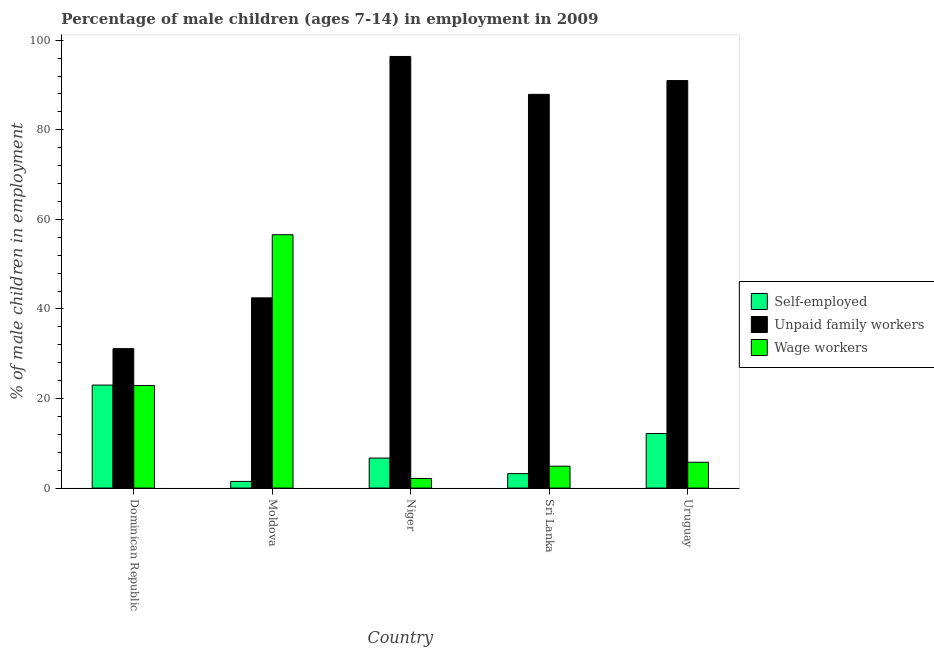How many groups of bars are there?
Your answer should be very brief. 5. Are the number of bars per tick equal to the number of legend labels?
Keep it short and to the point. Yes. Are the number of bars on each tick of the X-axis equal?
Make the answer very short. Yes. How many bars are there on the 2nd tick from the left?
Your answer should be compact. 3. How many bars are there on the 3rd tick from the right?
Your answer should be very brief. 3. What is the label of the 1st group of bars from the left?
Your answer should be very brief. Dominican Republic. What is the percentage of self employed children in Sri Lanka?
Your answer should be compact. 3.23. Across all countries, what is the maximum percentage of self employed children?
Offer a very short reply. 23. Across all countries, what is the minimum percentage of self employed children?
Offer a terse response. 1.49. In which country was the percentage of children employed as wage workers maximum?
Offer a terse response. Moldova. In which country was the percentage of children employed as unpaid family workers minimum?
Give a very brief answer. Dominican Republic. What is the total percentage of self employed children in the graph?
Keep it short and to the point. 46.6. What is the difference between the percentage of self employed children in Dominican Republic and that in Uruguay?
Your response must be concise. 10.82. What is the difference between the percentage of children employed as unpaid family workers in Niger and the percentage of children employed as wage workers in Moldova?
Provide a short and direct response. 39.81. What is the average percentage of children employed as wage workers per country?
Make the answer very short. 18.45. What is the difference between the percentage of children employed as wage workers and percentage of children employed as unpaid family workers in Moldova?
Make the answer very short. 14.09. In how many countries, is the percentage of children employed as unpaid family workers greater than 48 %?
Give a very brief answer. 3. What is the ratio of the percentage of self employed children in Moldova to that in Uruguay?
Make the answer very short. 0.12. Is the percentage of self employed children in Niger less than that in Uruguay?
Provide a succinct answer. Yes. Is the difference between the percentage of children employed as unpaid family workers in Niger and Sri Lanka greater than the difference between the percentage of children employed as wage workers in Niger and Sri Lanka?
Make the answer very short. Yes. What is the difference between the highest and the second highest percentage of children employed as wage workers?
Ensure brevity in your answer.  33.67. What is the difference between the highest and the lowest percentage of self employed children?
Your answer should be compact. 21.51. In how many countries, is the percentage of children employed as unpaid family workers greater than the average percentage of children employed as unpaid family workers taken over all countries?
Ensure brevity in your answer.  3. Is the sum of the percentage of children employed as unpaid family workers in Moldova and Uruguay greater than the maximum percentage of self employed children across all countries?
Keep it short and to the point. Yes. What does the 3rd bar from the left in Niger represents?
Provide a succinct answer. Wage workers. What does the 1st bar from the right in Dominican Republic represents?
Your answer should be compact. Wage workers. Are all the bars in the graph horizontal?
Your answer should be compact. No. How many countries are there in the graph?
Your response must be concise. 5. Are the values on the major ticks of Y-axis written in scientific E-notation?
Offer a very short reply. No. Does the graph contain grids?
Make the answer very short. No. Where does the legend appear in the graph?
Provide a succinct answer. Center right. How are the legend labels stacked?
Ensure brevity in your answer.  Vertical. What is the title of the graph?
Make the answer very short. Percentage of male children (ages 7-14) in employment in 2009. Does "Male employers" appear as one of the legend labels in the graph?
Give a very brief answer. No. What is the label or title of the Y-axis?
Your answer should be very brief. % of male children in employment. What is the % of male children in employment in Unpaid family workers in Dominican Republic?
Ensure brevity in your answer.  31.14. What is the % of male children in employment of Wage workers in Dominican Republic?
Provide a succinct answer. 22.9. What is the % of male children in employment in Self-employed in Moldova?
Your response must be concise. 1.49. What is the % of male children in employment in Unpaid family workers in Moldova?
Your response must be concise. 42.48. What is the % of male children in employment of Wage workers in Moldova?
Your answer should be very brief. 56.57. What is the % of male children in employment in Unpaid family workers in Niger?
Ensure brevity in your answer.  96.38. What is the % of male children in employment of Wage workers in Niger?
Offer a very short reply. 2.14. What is the % of male children in employment in Self-employed in Sri Lanka?
Provide a short and direct response. 3.23. What is the % of male children in employment in Unpaid family workers in Sri Lanka?
Provide a succinct answer. 87.92. What is the % of male children in employment of Wage workers in Sri Lanka?
Ensure brevity in your answer.  4.89. What is the % of male children in employment of Self-employed in Uruguay?
Ensure brevity in your answer.  12.18. What is the % of male children in employment of Unpaid family workers in Uruguay?
Offer a terse response. 91. What is the % of male children in employment of Wage workers in Uruguay?
Keep it short and to the point. 5.77. Across all countries, what is the maximum % of male children in employment in Self-employed?
Make the answer very short. 23. Across all countries, what is the maximum % of male children in employment of Unpaid family workers?
Provide a short and direct response. 96.38. Across all countries, what is the maximum % of male children in employment of Wage workers?
Provide a short and direct response. 56.57. Across all countries, what is the minimum % of male children in employment in Self-employed?
Provide a succinct answer. 1.49. Across all countries, what is the minimum % of male children in employment in Unpaid family workers?
Your answer should be compact. 31.14. Across all countries, what is the minimum % of male children in employment of Wage workers?
Offer a very short reply. 2.14. What is the total % of male children in employment of Self-employed in the graph?
Give a very brief answer. 46.6. What is the total % of male children in employment in Unpaid family workers in the graph?
Your response must be concise. 348.92. What is the total % of male children in employment of Wage workers in the graph?
Keep it short and to the point. 92.27. What is the difference between the % of male children in employment in Self-employed in Dominican Republic and that in Moldova?
Provide a short and direct response. 21.51. What is the difference between the % of male children in employment in Unpaid family workers in Dominican Republic and that in Moldova?
Give a very brief answer. -11.34. What is the difference between the % of male children in employment of Wage workers in Dominican Republic and that in Moldova?
Offer a terse response. -33.67. What is the difference between the % of male children in employment of Self-employed in Dominican Republic and that in Niger?
Provide a short and direct response. 16.3. What is the difference between the % of male children in employment in Unpaid family workers in Dominican Republic and that in Niger?
Your answer should be very brief. -65.24. What is the difference between the % of male children in employment in Wage workers in Dominican Republic and that in Niger?
Make the answer very short. 20.76. What is the difference between the % of male children in employment of Self-employed in Dominican Republic and that in Sri Lanka?
Provide a short and direct response. 19.77. What is the difference between the % of male children in employment in Unpaid family workers in Dominican Republic and that in Sri Lanka?
Offer a very short reply. -56.78. What is the difference between the % of male children in employment in Wage workers in Dominican Republic and that in Sri Lanka?
Your answer should be very brief. 18.01. What is the difference between the % of male children in employment in Self-employed in Dominican Republic and that in Uruguay?
Your answer should be compact. 10.82. What is the difference between the % of male children in employment of Unpaid family workers in Dominican Republic and that in Uruguay?
Give a very brief answer. -59.86. What is the difference between the % of male children in employment in Wage workers in Dominican Republic and that in Uruguay?
Keep it short and to the point. 17.13. What is the difference between the % of male children in employment in Self-employed in Moldova and that in Niger?
Make the answer very short. -5.21. What is the difference between the % of male children in employment in Unpaid family workers in Moldova and that in Niger?
Offer a terse response. -53.9. What is the difference between the % of male children in employment in Wage workers in Moldova and that in Niger?
Your answer should be compact. 54.43. What is the difference between the % of male children in employment of Self-employed in Moldova and that in Sri Lanka?
Provide a short and direct response. -1.74. What is the difference between the % of male children in employment of Unpaid family workers in Moldova and that in Sri Lanka?
Your answer should be compact. -45.44. What is the difference between the % of male children in employment of Wage workers in Moldova and that in Sri Lanka?
Keep it short and to the point. 51.68. What is the difference between the % of male children in employment of Self-employed in Moldova and that in Uruguay?
Provide a short and direct response. -10.69. What is the difference between the % of male children in employment in Unpaid family workers in Moldova and that in Uruguay?
Your answer should be compact. -48.52. What is the difference between the % of male children in employment of Wage workers in Moldova and that in Uruguay?
Keep it short and to the point. 50.8. What is the difference between the % of male children in employment of Self-employed in Niger and that in Sri Lanka?
Your answer should be compact. 3.47. What is the difference between the % of male children in employment of Unpaid family workers in Niger and that in Sri Lanka?
Offer a very short reply. 8.46. What is the difference between the % of male children in employment of Wage workers in Niger and that in Sri Lanka?
Your answer should be compact. -2.75. What is the difference between the % of male children in employment of Self-employed in Niger and that in Uruguay?
Provide a short and direct response. -5.48. What is the difference between the % of male children in employment of Unpaid family workers in Niger and that in Uruguay?
Provide a succinct answer. 5.38. What is the difference between the % of male children in employment of Wage workers in Niger and that in Uruguay?
Offer a very short reply. -3.63. What is the difference between the % of male children in employment in Self-employed in Sri Lanka and that in Uruguay?
Make the answer very short. -8.95. What is the difference between the % of male children in employment in Unpaid family workers in Sri Lanka and that in Uruguay?
Offer a very short reply. -3.08. What is the difference between the % of male children in employment in Wage workers in Sri Lanka and that in Uruguay?
Ensure brevity in your answer.  -0.88. What is the difference between the % of male children in employment in Self-employed in Dominican Republic and the % of male children in employment in Unpaid family workers in Moldova?
Your answer should be very brief. -19.48. What is the difference between the % of male children in employment in Self-employed in Dominican Republic and the % of male children in employment in Wage workers in Moldova?
Keep it short and to the point. -33.57. What is the difference between the % of male children in employment of Unpaid family workers in Dominican Republic and the % of male children in employment of Wage workers in Moldova?
Provide a short and direct response. -25.43. What is the difference between the % of male children in employment of Self-employed in Dominican Republic and the % of male children in employment of Unpaid family workers in Niger?
Make the answer very short. -73.38. What is the difference between the % of male children in employment of Self-employed in Dominican Republic and the % of male children in employment of Wage workers in Niger?
Offer a very short reply. 20.86. What is the difference between the % of male children in employment in Unpaid family workers in Dominican Republic and the % of male children in employment in Wage workers in Niger?
Make the answer very short. 29. What is the difference between the % of male children in employment in Self-employed in Dominican Republic and the % of male children in employment in Unpaid family workers in Sri Lanka?
Your answer should be very brief. -64.92. What is the difference between the % of male children in employment in Self-employed in Dominican Republic and the % of male children in employment in Wage workers in Sri Lanka?
Keep it short and to the point. 18.11. What is the difference between the % of male children in employment in Unpaid family workers in Dominican Republic and the % of male children in employment in Wage workers in Sri Lanka?
Provide a succinct answer. 26.25. What is the difference between the % of male children in employment in Self-employed in Dominican Republic and the % of male children in employment in Unpaid family workers in Uruguay?
Provide a succinct answer. -68. What is the difference between the % of male children in employment in Self-employed in Dominican Republic and the % of male children in employment in Wage workers in Uruguay?
Provide a succinct answer. 17.23. What is the difference between the % of male children in employment of Unpaid family workers in Dominican Republic and the % of male children in employment of Wage workers in Uruguay?
Your answer should be compact. 25.37. What is the difference between the % of male children in employment in Self-employed in Moldova and the % of male children in employment in Unpaid family workers in Niger?
Keep it short and to the point. -94.89. What is the difference between the % of male children in employment of Self-employed in Moldova and the % of male children in employment of Wage workers in Niger?
Provide a short and direct response. -0.65. What is the difference between the % of male children in employment in Unpaid family workers in Moldova and the % of male children in employment in Wage workers in Niger?
Offer a very short reply. 40.34. What is the difference between the % of male children in employment of Self-employed in Moldova and the % of male children in employment of Unpaid family workers in Sri Lanka?
Keep it short and to the point. -86.43. What is the difference between the % of male children in employment of Unpaid family workers in Moldova and the % of male children in employment of Wage workers in Sri Lanka?
Give a very brief answer. 37.59. What is the difference between the % of male children in employment of Self-employed in Moldova and the % of male children in employment of Unpaid family workers in Uruguay?
Your answer should be very brief. -89.51. What is the difference between the % of male children in employment of Self-employed in Moldova and the % of male children in employment of Wage workers in Uruguay?
Keep it short and to the point. -4.28. What is the difference between the % of male children in employment in Unpaid family workers in Moldova and the % of male children in employment in Wage workers in Uruguay?
Your answer should be very brief. 36.71. What is the difference between the % of male children in employment in Self-employed in Niger and the % of male children in employment in Unpaid family workers in Sri Lanka?
Make the answer very short. -81.22. What is the difference between the % of male children in employment in Self-employed in Niger and the % of male children in employment in Wage workers in Sri Lanka?
Offer a terse response. 1.81. What is the difference between the % of male children in employment of Unpaid family workers in Niger and the % of male children in employment of Wage workers in Sri Lanka?
Keep it short and to the point. 91.49. What is the difference between the % of male children in employment in Self-employed in Niger and the % of male children in employment in Unpaid family workers in Uruguay?
Keep it short and to the point. -84.3. What is the difference between the % of male children in employment in Unpaid family workers in Niger and the % of male children in employment in Wage workers in Uruguay?
Provide a short and direct response. 90.61. What is the difference between the % of male children in employment in Self-employed in Sri Lanka and the % of male children in employment in Unpaid family workers in Uruguay?
Provide a short and direct response. -87.77. What is the difference between the % of male children in employment in Self-employed in Sri Lanka and the % of male children in employment in Wage workers in Uruguay?
Your response must be concise. -2.54. What is the difference between the % of male children in employment in Unpaid family workers in Sri Lanka and the % of male children in employment in Wage workers in Uruguay?
Your answer should be very brief. 82.15. What is the average % of male children in employment in Self-employed per country?
Offer a terse response. 9.32. What is the average % of male children in employment of Unpaid family workers per country?
Offer a terse response. 69.78. What is the average % of male children in employment of Wage workers per country?
Make the answer very short. 18.45. What is the difference between the % of male children in employment in Self-employed and % of male children in employment in Unpaid family workers in Dominican Republic?
Your response must be concise. -8.14. What is the difference between the % of male children in employment in Unpaid family workers and % of male children in employment in Wage workers in Dominican Republic?
Ensure brevity in your answer.  8.24. What is the difference between the % of male children in employment of Self-employed and % of male children in employment of Unpaid family workers in Moldova?
Give a very brief answer. -40.99. What is the difference between the % of male children in employment of Self-employed and % of male children in employment of Wage workers in Moldova?
Provide a succinct answer. -55.08. What is the difference between the % of male children in employment in Unpaid family workers and % of male children in employment in Wage workers in Moldova?
Keep it short and to the point. -14.09. What is the difference between the % of male children in employment in Self-employed and % of male children in employment in Unpaid family workers in Niger?
Keep it short and to the point. -89.68. What is the difference between the % of male children in employment of Self-employed and % of male children in employment of Wage workers in Niger?
Your answer should be very brief. 4.56. What is the difference between the % of male children in employment in Unpaid family workers and % of male children in employment in Wage workers in Niger?
Keep it short and to the point. 94.24. What is the difference between the % of male children in employment of Self-employed and % of male children in employment of Unpaid family workers in Sri Lanka?
Make the answer very short. -84.69. What is the difference between the % of male children in employment in Self-employed and % of male children in employment in Wage workers in Sri Lanka?
Make the answer very short. -1.66. What is the difference between the % of male children in employment of Unpaid family workers and % of male children in employment of Wage workers in Sri Lanka?
Provide a succinct answer. 83.03. What is the difference between the % of male children in employment of Self-employed and % of male children in employment of Unpaid family workers in Uruguay?
Keep it short and to the point. -78.82. What is the difference between the % of male children in employment of Self-employed and % of male children in employment of Wage workers in Uruguay?
Provide a succinct answer. 6.41. What is the difference between the % of male children in employment of Unpaid family workers and % of male children in employment of Wage workers in Uruguay?
Provide a succinct answer. 85.23. What is the ratio of the % of male children in employment in Self-employed in Dominican Republic to that in Moldova?
Give a very brief answer. 15.44. What is the ratio of the % of male children in employment in Unpaid family workers in Dominican Republic to that in Moldova?
Offer a terse response. 0.73. What is the ratio of the % of male children in employment of Wage workers in Dominican Republic to that in Moldova?
Offer a terse response. 0.4. What is the ratio of the % of male children in employment of Self-employed in Dominican Republic to that in Niger?
Provide a succinct answer. 3.43. What is the ratio of the % of male children in employment in Unpaid family workers in Dominican Republic to that in Niger?
Provide a short and direct response. 0.32. What is the ratio of the % of male children in employment of Wage workers in Dominican Republic to that in Niger?
Your response must be concise. 10.7. What is the ratio of the % of male children in employment in Self-employed in Dominican Republic to that in Sri Lanka?
Your answer should be compact. 7.12. What is the ratio of the % of male children in employment in Unpaid family workers in Dominican Republic to that in Sri Lanka?
Keep it short and to the point. 0.35. What is the ratio of the % of male children in employment of Wage workers in Dominican Republic to that in Sri Lanka?
Provide a succinct answer. 4.68. What is the ratio of the % of male children in employment of Self-employed in Dominican Republic to that in Uruguay?
Provide a short and direct response. 1.89. What is the ratio of the % of male children in employment of Unpaid family workers in Dominican Republic to that in Uruguay?
Your response must be concise. 0.34. What is the ratio of the % of male children in employment in Wage workers in Dominican Republic to that in Uruguay?
Give a very brief answer. 3.97. What is the ratio of the % of male children in employment in Self-employed in Moldova to that in Niger?
Your response must be concise. 0.22. What is the ratio of the % of male children in employment of Unpaid family workers in Moldova to that in Niger?
Ensure brevity in your answer.  0.44. What is the ratio of the % of male children in employment in Wage workers in Moldova to that in Niger?
Make the answer very short. 26.43. What is the ratio of the % of male children in employment in Self-employed in Moldova to that in Sri Lanka?
Offer a very short reply. 0.46. What is the ratio of the % of male children in employment in Unpaid family workers in Moldova to that in Sri Lanka?
Your answer should be very brief. 0.48. What is the ratio of the % of male children in employment of Wage workers in Moldova to that in Sri Lanka?
Give a very brief answer. 11.57. What is the ratio of the % of male children in employment of Self-employed in Moldova to that in Uruguay?
Give a very brief answer. 0.12. What is the ratio of the % of male children in employment of Unpaid family workers in Moldova to that in Uruguay?
Make the answer very short. 0.47. What is the ratio of the % of male children in employment in Wage workers in Moldova to that in Uruguay?
Make the answer very short. 9.8. What is the ratio of the % of male children in employment in Self-employed in Niger to that in Sri Lanka?
Your response must be concise. 2.07. What is the ratio of the % of male children in employment in Unpaid family workers in Niger to that in Sri Lanka?
Provide a succinct answer. 1.1. What is the ratio of the % of male children in employment in Wage workers in Niger to that in Sri Lanka?
Your answer should be compact. 0.44. What is the ratio of the % of male children in employment in Self-employed in Niger to that in Uruguay?
Ensure brevity in your answer.  0.55. What is the ratio of the % of male children in employment in Unpaid family workers in Niger to that in Uruguay?
Provide a succinct answer. 1.06. What is the ratio of the % of male children in employment in Wage workers in Niger to that in Uruguay?
Offer a very short reply. 0.37. What is the ratio of the % of male children in employment in Self-employed in Sri Lanka to that in Uruguay?
Offer a terse response. 0.27. What is the ratio of the % of male children in employment of Unpaid family workers in Sri Lanka to that in Uruguay?
Provide a short and direct response. 0.97. What is the ratio of the % of male children in employment of Wage workers in Sri Lanka to that in Uruguay?
Ensure brevity in your answer.  0.85. What is the difference between the highest and the second highest % of male children in employment in Self-employed?
Give a very brief answer. 10.82. What is the difference between the highest and the second highest % of male children in employment of Unpaid family workers?
Ensure brevity in your answer.  5.38. What is the difference between the highest and the second highest % of male children in employment of Wage workers?
Your answer should be compact. 33.67. What is the difference between the highest and the lowest % of male children in employment in Self-employed?
Offer a terse response. 21.51. What is the difference between the highest and the lowest % of male children in employment of Unpaid family workers?
Your response must be concise. 65.24. What is the difference between the highest and the lowest % of male children in employment in Wage workers?
Make the answer very short. 54.43. 